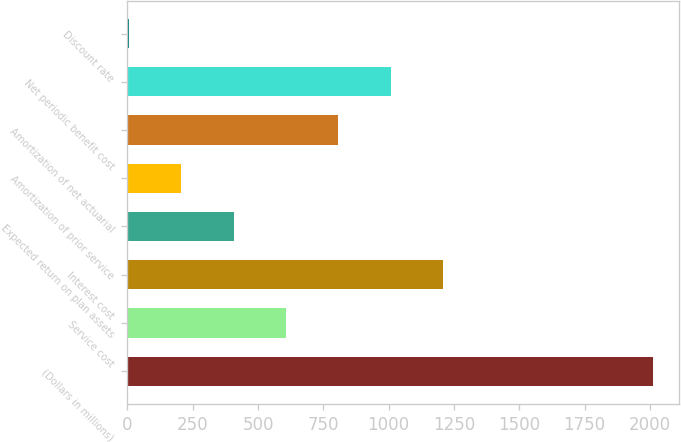Convert chart. <chart><loc_0><loc_0><loc_500><loc_500><bar_chart><fcel>(Dollars in millions)<fcel>Service cost<fcel>Interest cost<fcel>Expected return on plan assets<fcel>Amortization of prior service<fcel>Amortization of net actuarial<fcel>Net periodic benefit cost<fcel>Discount rate<nl><fcel>2010<fcel>607.04<fcel>1208.31<fcel>406.61<fcel>206.18<fcel>807.46<fcel>1007.88<fcel>5.75<nl></chart> 